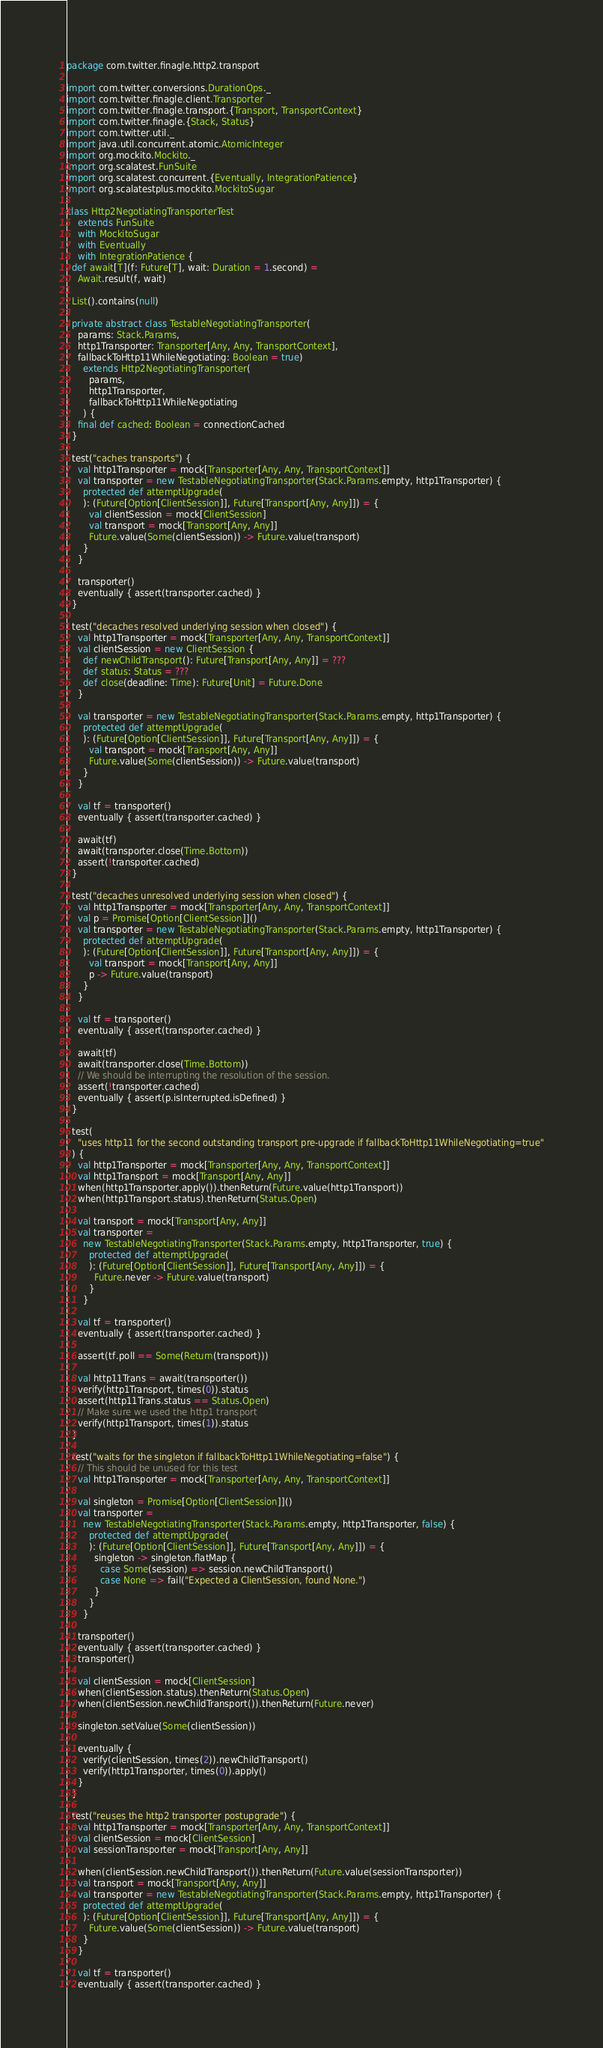<code> <loc_0><loc_0><loc_500><loc_500><_Scala_>package com.twitter.finagle.http2.transport

import com.twitter.conversions.DurationOps._
import com.twitter.finagle.client.Transporter
import com.twitter.finagle.transport.{Transport, TransportContext}
import com.twitter.finagle.{Stack, Status}
import com.twitter.util._
import java.util.concurrent.atomic.AtomicInteger
import org.mockito.Mockito._
import org.scalatest.FunSuite
import org.scalatest.concurrent.{Eventually, IntegrationPatience}
import org.scalatestplus.mockito.MockitoSugar

class Http2NegotiatingTransporterTest
    extends FunSuite
    with MockitoSugar
    with Eventually
    with IntegrationPatience {
  def await[T](f: Future[T], wait: Duration = 1.second) =
    Await.result(f, wait)

  List().contains(null)

  private abstract class TestableNegotiatingTransporter(
    params: Stack.Params,
    http1Transporter: Transporter[Any, Any, TransportContext],
    fallbackToHttp11WhileNegotiating: Boolean = true)
      extends Http2NegotiatingTransporter(
        params,
        http1Transporter,
        fallbackToHttp11WhileNegotiating
      ) {
    final def cached: Boolean = connectionCached
  }

  test("caches transports") {
    val http1Transporter = mock[Transporter[Any, Any, TransportContext]]
    val transporter = new TestableNegotiatingTransporter(Stack.Params.empty, http1Transporter) {
      protected def attemptUpgrade(
      ): (Future[Option[ClientSession]], Future[Transport[Any, Any]]) = {
        val clientSession = mock[ClientSession]
        val transport = mock[Transport[Any, Any]]
        Future.value(Some(clientSession)) -> Future.value(transport)
      }
    }

    transporter()
    eventually { assert(transporter.cached) }
  }

  test("decaches resolved underlying session when closed") {
    val http1Transporter = mock[Transporter[Any, Any, TransportContext]]
    val clientSession = new ClientSession {
      def newChildTransport(): Future[Transport[Any, Any]] = ???
      def status: Status = ???
      def close(deadline: Time): Future[Unit] = Future.Done
    }

    val transporter = new TestableNegotiatingTransporter(Stack.Params.empty, http1Transporter) {
      protected def attemptUpgrade(
      ): (Future[Option[ClientSession]], Future[Transport[Any, Any]]) = {
        val transport = mock[Transport[Any, Any]]
        Future.value(Some(clientSession)) -> Future.value(transport)
      }
    }

    val tf = transporter()
    eventually { assert(transporter.cached) }

    await(tf)
    await(transporter.close(Time.Bottom))
    assert(!transporter.cached)
  }

  test("decaches unresolved underlying session when closed") {
    val http1Transporter = mock[Transporter[Any, Any, TransportContext]]
    val p = Promise[Option[ClientSession]]()
    val transporter = new TestableNegotiatingTransporter(Stack.Params.empty, http1Transporter) {
      protected def attemptUpgrade(
      ): (Future[Option[ClientSession]], Future[Transport[Any, Any]]) = {
        val transport = mock[Transport[Any, Any]]
        p -> Future.value(transport)
      }
    }

    val tf = transporter()
    eventually { assert(transporter.cached) }

    await(tf)
    await(transporter.close(Time.Bottom))
    // We should be interrupting the resolution of the session.
    assert(!transporter.cached)
    eventually { assert(p.isInterrupted.isDefined) }
  }

  test(
    "uses http11 for the second outstanding transport pre-upgrade if fallbackToHttp11WhileNegotiating=true"
  ) {
    val http1Transporter = mock[Transporter[Any, Any, TransportContext]]
    val http1Transport = mock[Transport[Any, Any]]
    when(http1Transporter.apply()).thenReturn(Future.value(http1Transport))
    when(http1Transport.status).thenReturn(Status.Open)

    val transport = mock[Transport[Any, Any]]
    val transporter =
      new TestableNegotiatingTransporter(Stack.Params.empty, http1Transporter, true) {
        protected def attemptUpgrade(
        ): (Future[Option[ClientSession]], Future[Transport[Any, Any]]) = {
          Future.never -> Future.value(transport)
        }
      }

    val tf = transporter()
    eventually { assert(transporter.cached) }

    assert(tf.poll == Some(Return(transport)))

    val http11Trans = await(transporter())
    verify(http1Transport, times(0)).status
    assert(http11Trans.status == Status.Open)
    // Make sure we used the http1 transport
    verify(http1Transport, times(1)).status
  }

  test("waits for the singleton if fallbackToHttp11WhileNegotiating=false") {
    // This should be unused for this test
    val http1Transporter = mock[Transporter[Any, Any, TransportContext]]

    val singleton = Promise[Option[ClientSession]]()
    val transporter =
      new TestableNegotiatingTransporter(Stack.Params.empty, http1Transporter, false) {
        protected def attemptUpgrade(
        ): (Future[Option[ClientSession]], Future[Transport[Any, Any]]) = {
          singleton -> singleton.flatMap {
            case Some(session) => session.newChildTransport()
            case None => fail("Expected a ClientSession, found None.")
          }
        }
      }

    transporter()
    eventually { assert(transporter.cached) }
    transporter()

    val clientSession = mock[ClientSession]
    when(clientSession.status).thenReturn(Status.Open)
    when(clientSession.newChildTransport()).thenReturn(Future.never)

    singleton.setValue(Some(clientSession))

    eventually {
      verify(clientSession, times(2)).newChildTransport()
      verify(http1Transporter, times(0)).apply()
    }
  }

  test("reuses the http2 transporter postupgrade") {
    val http1Transporter = mock[Transporter[Any, Any, TransportContext]]
    val clientSession = mock[ClientSession]
    val sessionTransporter = mock[Transport[Any, Any]]

    when(clientSession.newChildTransport()).thenReturn(Future.value(sessionTransporter))
    val transport = mock[Transport[Any, Any]]
    val transporter = new TestableNegotiatingTransporter(Stack.Params.empty, http1Transporter) {
      protected def attemptUpgrade(
      ): (Future[Option[ClientSession]], Future[Transport[Any, Any]]) = {
        Future.value(Some(clientSession)) -> Future.value(transport)
      }
    }

    val tf = transporter()
    eventually { assert(transporter.cached) }
</code> 